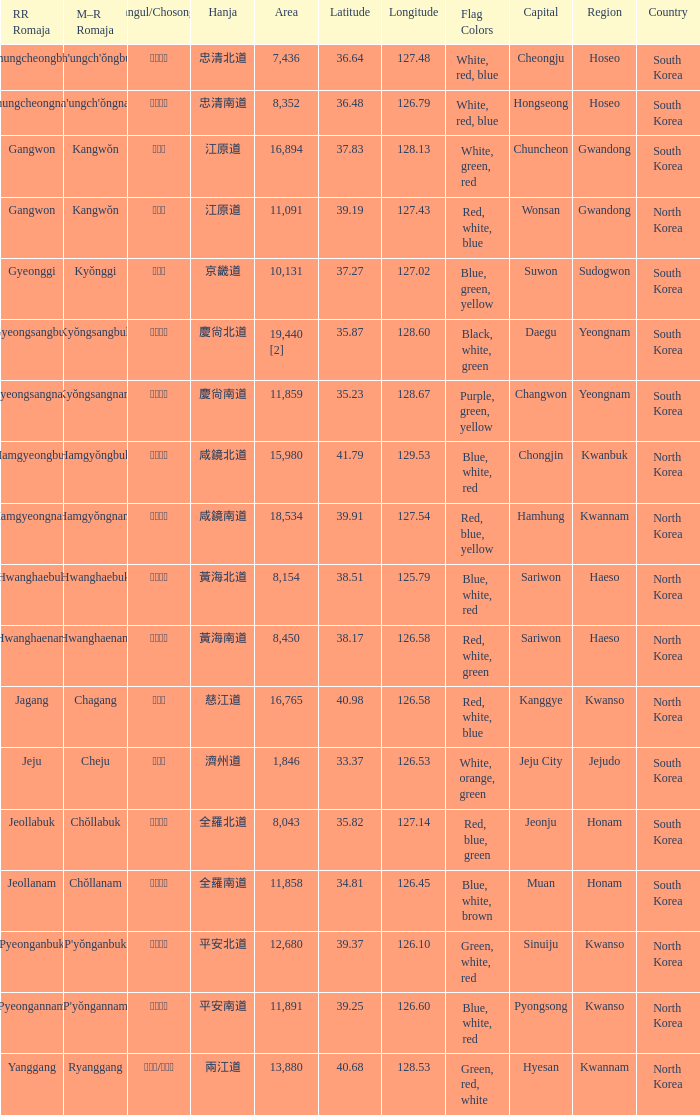What is the RR Romaja for the province that has Hangul of 강원도 and capital of Wonsan? Gangwon. 